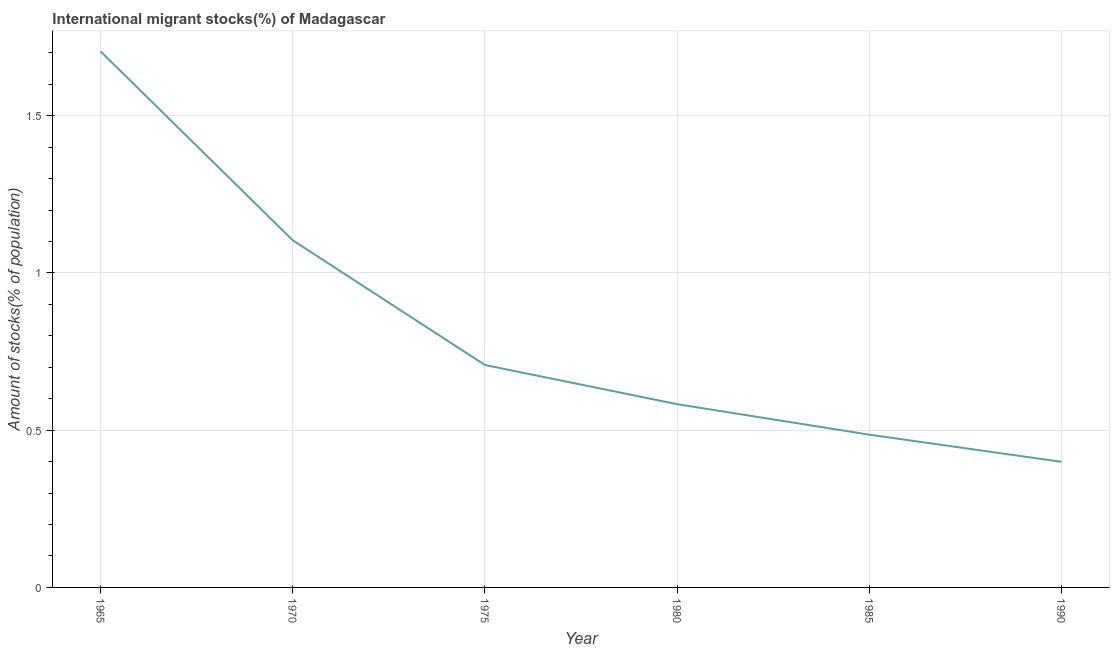What is the number of international migrant stocks in 1980?
Keep it short and to the point. 0.58. Across all years, what is the maximum number of international migrant stocks?
Offer a terse response. 1.7. Across all years, what is the minimum number of international migrant stocks?
Give a very brief answer. 0.4. In which year was the number of international migrant stocks maximum?
Your answer should be very brief. 1965. In which year was the number of international migrant stocks minimum?
Offer a terse response. 1990. What is the sum of the number of international migrant stocks?
Your response must be concise. 4.98. What is the difference between the number of international migrant stocks in 1970 and 1975?
Your response must be concise. 0.4. What is the average number of international migrant stocks per year?
Ensure brevity in your answer.  0.83. What is the median number of international migrant stocks?
Your response must be concise. 0.65. In how many years, is the number of international migrant stocks greater than 1.5 %?
Offer a terse response. 1. What is the ratio of the number of international migrant stocks in 1970 to that in 1980?
Ensure brevity in your answer.  1.89. Is the number of international migrant stocks in 1970 less than that in 1985?
Provide a short and direct response. No. Is the difference between the number of international migrant stocks in 1965 and 1985 greater than the difference between any two years?
Your answer should be very brief. No. What is the difference between the highest and the second highest number of international migrant stocks?
Keep it short and to the point. 0.6. What is the difference between the highest and the lowest number of international migrant stocks?
Ensure brevity in your answer.  1.31. In how many years, is the number of international migrant stocks greater than the average number of international migrant stocks taken over all years?
Your response must be concise. 2. Does the number of international migrant stocks monotonically increase over the years?
Ensure brevity in your answer.  No. Are the values on the major ticks of Y-axis written in scientific E-notation?
Keep it short and to the point. No. Does the graph contain any zero values?
Ensure brevity in your answer.  No. What is the title of the graph?
Make the answer very short. International migrant stocks(%) of Madagascar. What is the label or title of the Y-axis?
Your answer should be very brief. Amount of stocks(% of population). What is the Amount of stocks(% of population) in 1965?
Your response must be concise. 1.7. What is the Amount of stocks(% of population) of 1970?
Offer a very short reply. 1.1. What is the Amount of stocks(% of population) of 1975?
Offer a terse response. 0.71. What is the Amount of stocks(% of population) of 1980?
Give a very brief answer. 0.58. What is the Amount of stocks(% of population) of 1985?
Provide a short and direct response. 0.49. What is the Amount of stocks(% of population) in 1990?
Provide a short and direct response. 0.4. What is the difference between the Amount of stocks(% of population) in 1965 and 1970?
Offer a terse response. 0.6. What is the difference between the Amount of stocks(% of population) in 1965 and 1975?
Your answer should be compact. 1. What is the difference between the Amount of stocks(% of population) in 1965 and 1980?
Make the answer very short. 1.12. What is the difference between the Amount of stocks(% of population) in 1965 and 1985?
Keep it short and to the point. 1.22. What is the difference between the Amount of stocks(% of population) in 1965 and 1990?
Offer a terse response. 1.31. What is the difference between the Amount of stocks(% of population) in 1970 and 1975?
Your answer should be compact. 0.4. What is the difference between the Amount of stocks(% of population) in 1970 and 1980?
Offer a very short reply. 0.52. What is the difference between the Amount of stocks(% of population) in 1970 and 1985?
Your response must be concise. 0.62. What is the difference between the Amount of stocks(% of population) in 1970 and 1990?
Your answer should be very brief. 0.7. What is the difference between the Amount of stocks(% of population) in 1975 and 1980?
Provide a succinct answer. 0.12. What is the difference between the Amount of stocks(% of population) in 1975 and 1985?
Give a very brief answer. 0.22. What is the difference between the Amount of stocks(% of population) in 1975 and 1990?
Keep it short and to the point. 0.31. What is the difference between the Amount of stocks(% of population) in 1980 and 1985?
Make the answer very short. 0.1. What is the difference between the Amount of stocks(% of population) in 1980 and 1990?
Give a very brief answer. 0.18. What is the difference between the Amount of stocks(% of population) in 1985 and 1990?
Make the answer very short. 0.09. What is the ratio of the Amount of stocks(% of population) in 1965 to that in 1970?
Ensure brevity in your answer.  1.54. What is the ratio of the Amount of stocks(% of population) in 1965 to that in 1975?
Keep it short and to the point. 2.41. What is the ratio of the Amount of stocks(% of population) in 1965 to that in 1980?
Make the answer very short. 2.92. What is the ratio of the Amount of stocks(% of population) in 1965 to that in 1985?
Make the answer very short. 3.51. What is the ratio of the Amount of stocks(% of population) in 1965 to that in 1990?
Your response must be concise. 4.27. What is the ratio of the Amount of stocks(% of population) in 1970 to that in 1975?
Your answer should be very brief. 1.56. What is the ratio of the Amount of stocks(% of population) in 1970 to that in 1980?
Keep it short and to the point. 1.89. What is the ratio of the Amount of stocks(% of population) in 1970 to that in 1985?
Provide a short and direct response. 2.27. What is the ratio of the Amount of stocks(% of population) in 1970 to that in 1990?
Offer a terse response. 2.76. What is the ratio of the Amount of stocks(% of population) in 1975 to that in 1980?
Make the answer very short. 1.21. What is the ratio of the Amount of stocks(% of population) in 1975 to that in 1985?
Keep it short and to the point. 1.46. What is the ratio of the Amount of stocks(% of population) in 1975 to that in 1990?
Give a very brief answer. 1.77. What is the ratio of the Amount of stocks(% of population) in 1980 to that in 1990?
Provide a short and direct response. 1.46. What is the ratio of the Amount of stocks(% of population) in 1985 to that in 1990?
Offer a very short reply. 1.22. 